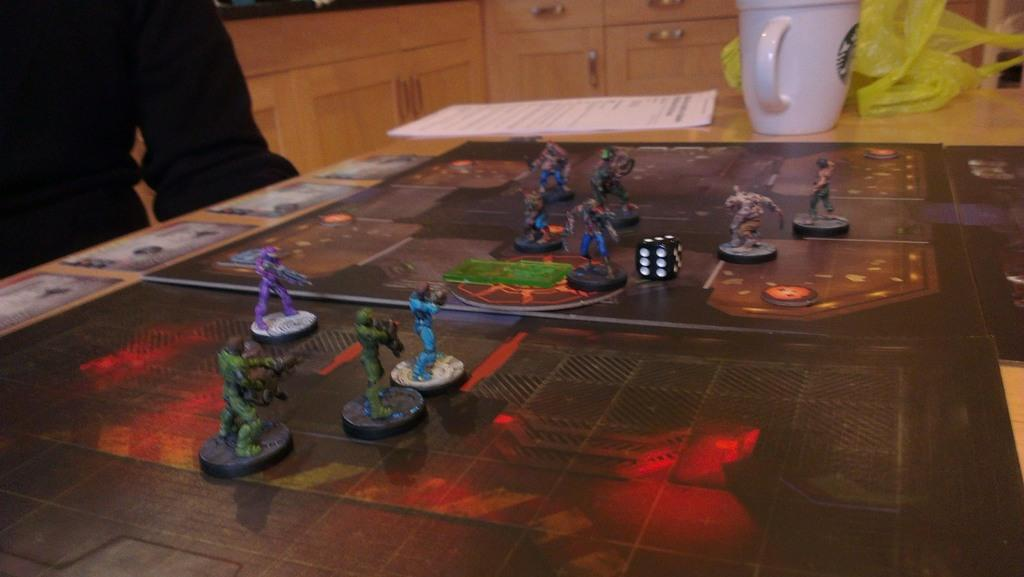What type of furniture can be seen in the background of the image? There are cupboards and a desk in the background of the image. What is on the table in the image? There are papers, a white cup, a cover, toys, coins, and a dice on the table in the image. Can you describe the objects on the table in more detail? The white cup is likely for holding a beverage, and the cover may be used to protect the items on the table. The toys and dice suggest that the table is being used for leisure or play. What type of machine is being used to make a drink in the image? There is no machine present in the image, nor is there any indication of a drink being made. What observation can be made about the toys on the table in the image? The toys on the table suggest that the table is being used for leisure or play, but there is no specific observation about the toys themselves that can be made from the image. 